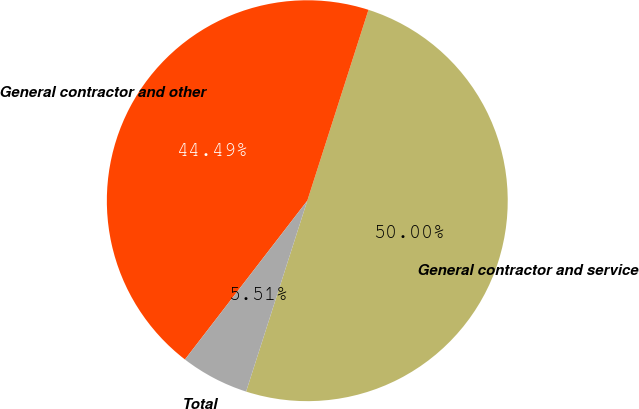Convert chart. <chart><loc_0><loc_0><loc_500><loc_500><pie_chart><fcel>General contractor and service<fcel>General contractor and other<fcel>Total<nl><fcel>50.0%<fcel>44.49%<fcel>5.51%<nl></chart> 